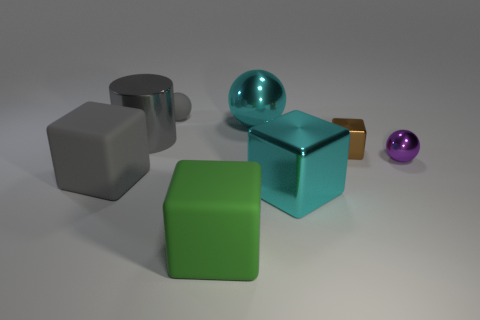There is a large green rubber object; what shape is it?
Give a very brief answer. Cube. What is the material of the tiny ball that is in front of the large thing that is behind the metal thing that is left of the green matte cube?
Ensure brevity in your answer.  Metal. What number of other things are there of the same material as the tiny block
Your answer should be compact. 4. There is a big gray object that is in front of the metallic cylinder; what number of rubber objects are to the right of it?
Offer a terse response. 2. How many cylinders are either large red shiny objects or tiny metal things?
Your answer should be compact. 0. There is a object that is behind the large gray cube and to the left of the small gray object; what is its color?
Ensure brevity in your answer.  Gray. Is there anything else that has the same color as the cylinder?
Offer a terse response. Yes. There is a block behind the large rubber object that is behind the large green rubber thing; what color is it?
Make the answer very short. Brown. Do the shiny cylinder and the cyan metal sphere have the same size?
Your answer should be very brief. Yes. Do the small ball that is on the right side of the small rubber ball and the gray thing behind the large sphere have the same material?
Your answer should be very brief. No. 